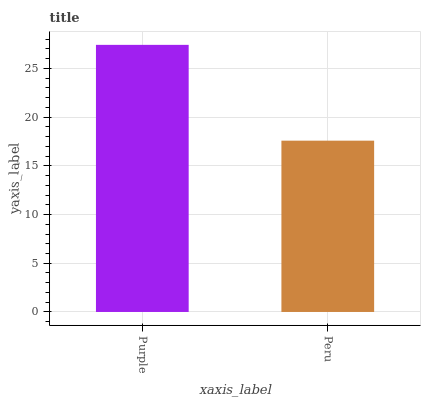Is Peru the minimum?
Answer yes or no. Yes. Is Purple the maximum?
Answer yes or no. Yes. Is Peru the maximum?
Answer yes or no. No. Is Purple greater than Peru?
Answer yes or no. Yes. Is Peru less than Purple?
Answer yes or no. Yes. Is Peru greater than Purple?
Answer yes or no. No. Is Purple less than Peru?
Answer yes or no. No. Is Purple the high median?
Answer yes or no. Yes. Is Peru the low median?
Answer yes or no. Yes. Is Peru the high median?
Answer yes or no. No. Is Purple the low median?
Answer yes or no. No. 